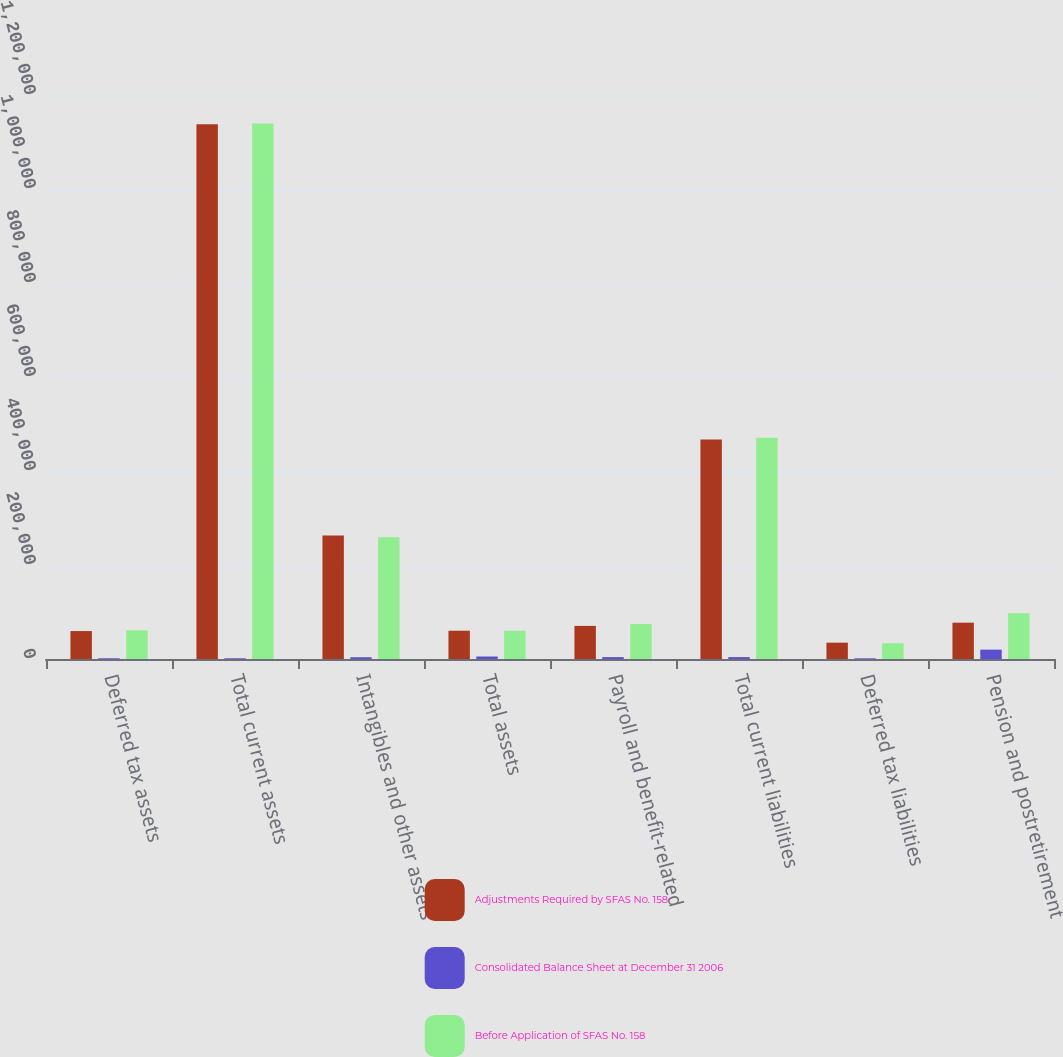Convert chart to OTSL. <chart><loc_0><loc_0><loc_500><loc_500><stacked_bar_chart><ecel><fcel>Deferred tax assets<fcel>Total current assets<fcel>Intangibles and other assets<fcel>Total assets<fcel>Payroll and benefit-related<fcel>Total current liabilities<fcel>Deferred tax liabilities<fcel>Pension and postretirement<nl><fcel>Adjustments Required by SFAS No. 158<fcel>59446<fcel>1.13801e+06<fcel>262991<fcel>60204.5<fcel>70413<fcel>466781<fcel>34774<fcel>77269<nl><fcel>Consolidated Balance Sheet at December 31 2006<fcel>1517<fcel>1517<fcel>3762<fcel>5322<fcel>3994<fcel>3994<fcel>1430<fcel>19922<nl><fcel>Before Application of SFAS No. 158<fcel>60963<fcel>1.13953e+06<fcel>259229<fcel>60204.5<fcel>74407<fcel>470775<fcel>33344<fcel>97191<nl></chart> 